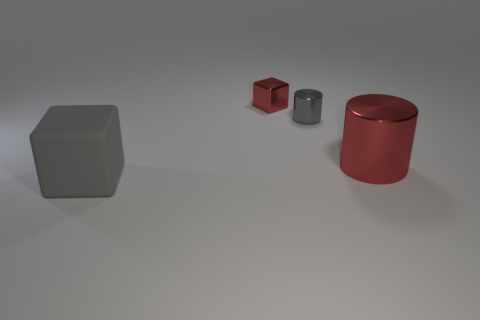How big is the red shiny cylinder?
Your response must be concise. Large. What color is the object that is in front of the small cylinder and behind the large gray matte block?
Give a very brief answer. Red. Do the rubber cube and the metal object that is right of the gray cylinder have the same size?
Make the answer very short. Yes. There is another metallic object that is the same shape as the big red shiny thing; what is its color?
Provide a succinct answer. Gray. Is the red metal cube the same size as the rubber cube?
Your answer should be very brief. No. How many other things are the same size as the red shiny block?
Your answer should be compact. 1. What number of objects are either big gray things on the left side of the small red shiny object or cubes right of the big gray matte block?
Provide a succinct answer. 2. The metal object that is the same size as the gray matte block is what shape?
Offer a terse response. Cylinder. There is another cylinder that is the same material as the small cylinder; what size is it?
Provide a succinct answer. Large. Is the shape of the small red shiny object the same as the gray rubber object?
Your answer should be very brief. Yes. 